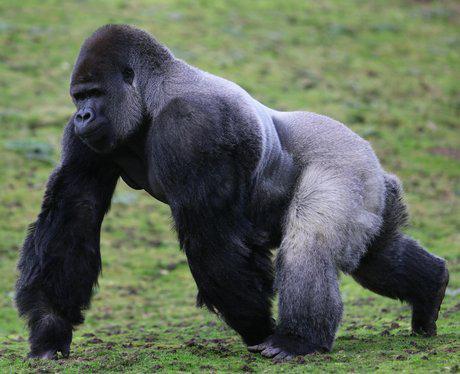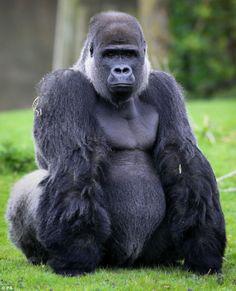The first image is the image on the left, the second image is the image on the right. For the images displayed, is the sentence "One of the animals is sitting on the ground." factually correct? Answer yes or no. Yes. The first image is the image on the left, the second image is the image on the right. For the images displayed, is the sentence "An image shows a large male gorilla on all fours, with body facing left." factually correct? Answer yes or no. Yes. 